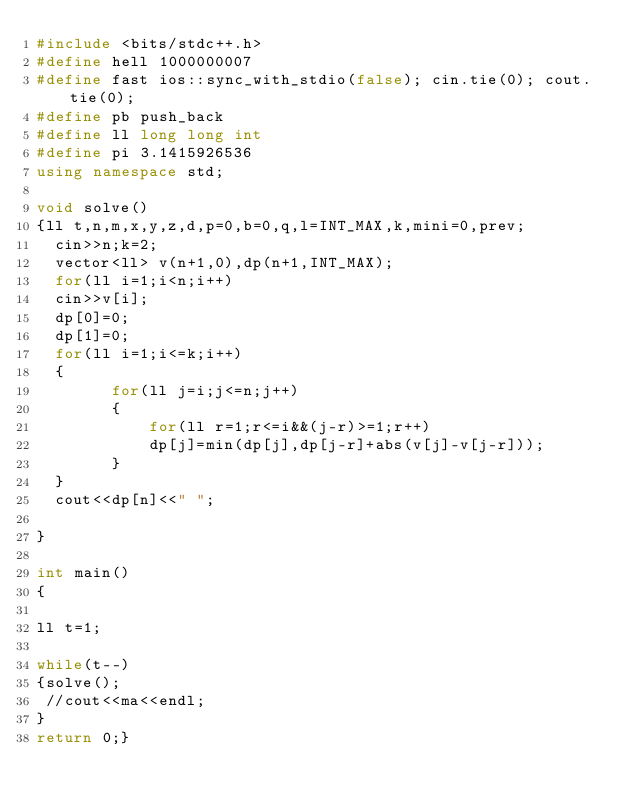<code> <loc_0><loc_0><loc_500><loc_500><_C++_>#include <bits/stdc++.h>
#define hell 1000000007
#define fast ios::sync_with_stdio(false); cin.tie(0); cout.tie(0);
#define pb push_back
#define ll long long int
#define pi 3.1415926536
using namespace std;

void solve()
{ll t,n,m,x,y,z,d,p=0,b=0,q,l=INT_MAX,k,mini=0,prev;
  cin>>n;k=2;
  vector<ll> v(n+1,0),dp(n+1,INT_MAX);
  for(ll i=1;i<n;i++)
  cin>>v[i];
  dp[0]=0;
  dp[1]=0;
  for(ll i=1;i<=k;i++)
  {
  		for(ll j=i;j<=n;j++)
  		{
  			for(ll r=1;r<=i&&(j-r)>=1;r++)
  			dp[j]=min(dp[j],dp[j-r]+abs(v[j]-v[j-r]));
		}
  }
  cout<<dp[n]<<" ";

}

int main()
{

ll t=1;

while(t--)
{solve();
 //cout<<ma<<endl;
}
return 0;}</code> 